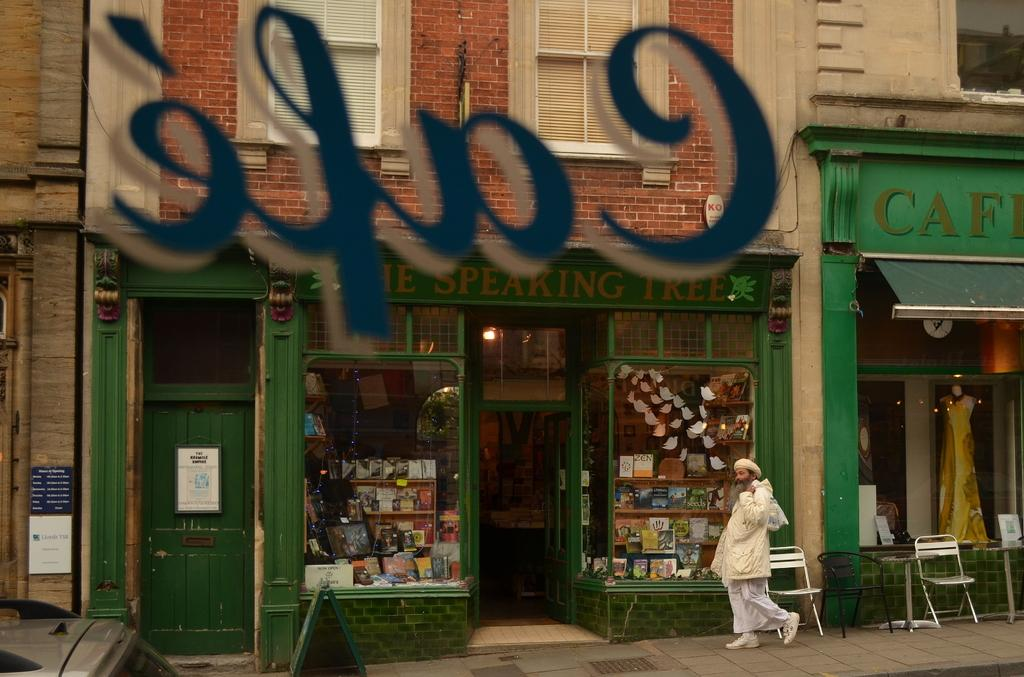<image>
Give a short and clear explanation of the subsequent image. A store is visible across the street through the cafe window. 